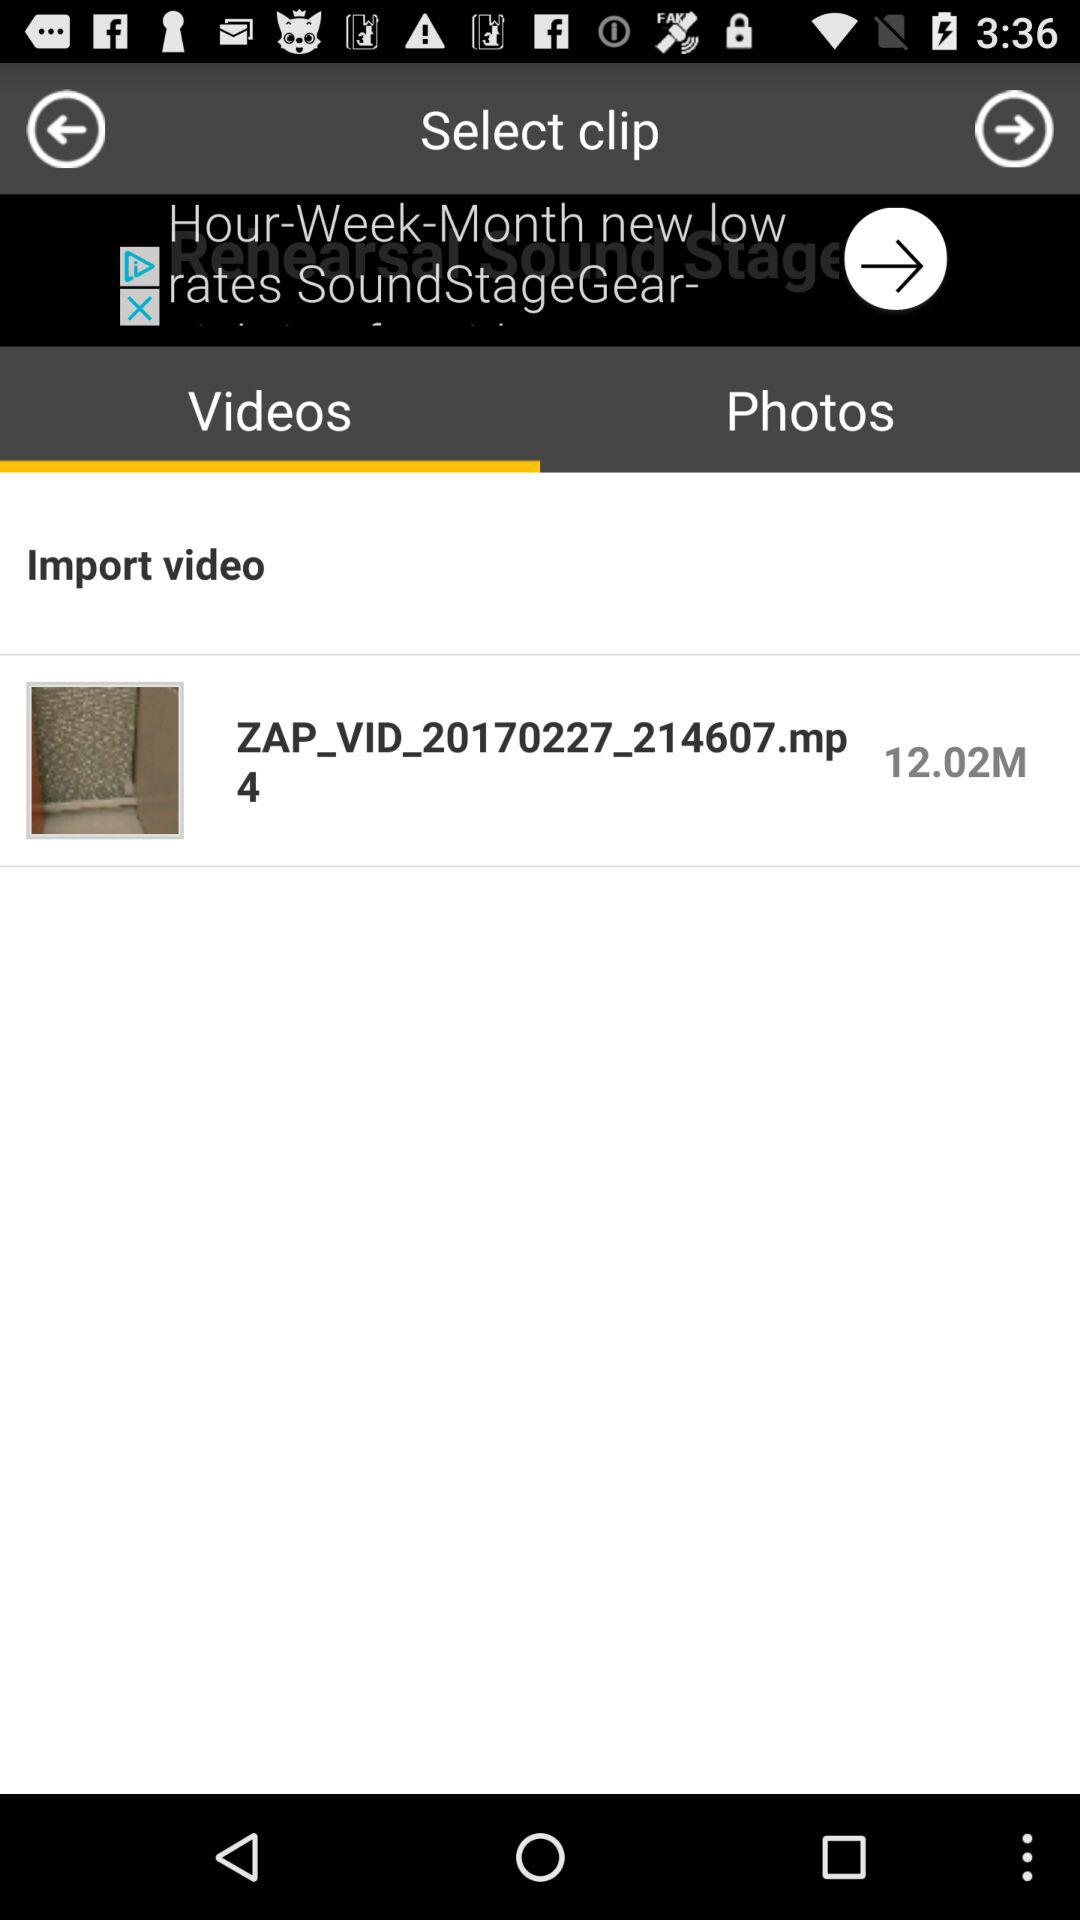Which tab is selected? The selected tab is "Videos". 